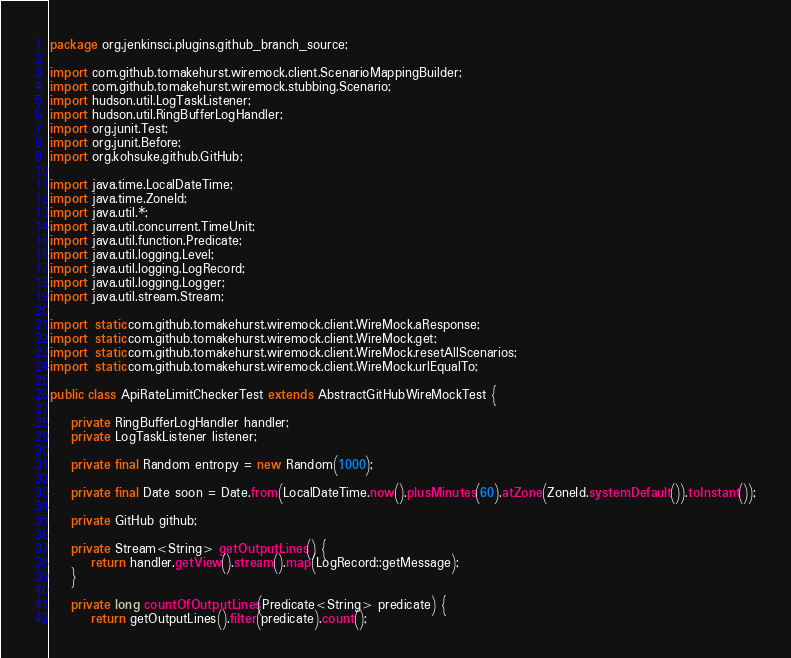Convert code to text. <code><loc_0><loc_0><loc_500><loc_500><_Java_>package org.jenkinsci.plugins.github_branch_source;

import com.github.tomakehurst.wiremock.client.ScenarioMappingBuilder;
import com.github.tomakehurst.wiremock.stubbing.Scenario;
import hudson.util.LogTaskListener;
import hudson.util.RingBufferLogHandler;
import org.junit.Test;
import org.junit.Before;
import org.kohsuke.github.GitHub;

import java.time.LocalDateTime;
import java.time.ZoneId;
import java.util.*;
import java.util.concurrent.TimeUnit;
import java.util.function.Predicate;
import java.util.logging.Level;
import java.util.logging.LogRecord;
import java.util.logging.Logger;
import java.util.stream.Stream;

import static com.github.tomakehurst.wiremock.client.WireMock.aResponse;
import static com.github.tomakehurst.wiremock.client.WireMock.get;
import static com.github.tomakehurst.wiremock.client.WireMock.resetAllScenarios;
import static com.github.tomakehurst.wiremock.client.WireMock.urlEqualTo;

public class ApiRateLimitCheckerTest extends AbstractGitHubWireMockTest {

    private RingBufferLogHandler handler;
    private LogTaskListener listener;

    private final Random entropy = new Random(1000);

    private final Date soon = Date.from(LocalDateTime.now().plusMinutes(60).atZone(ZoneId.systemDefault()).toInstant());

    private GitHub github;

    private Stream<String> getOutputLines() {
        return handler.getView().stream().map(LogRecord::getMessage);
    }

    private long countOfOutputLines(Predicate<String> predicate) {
        return getOutputLines().filter(predicate).count();</code> 